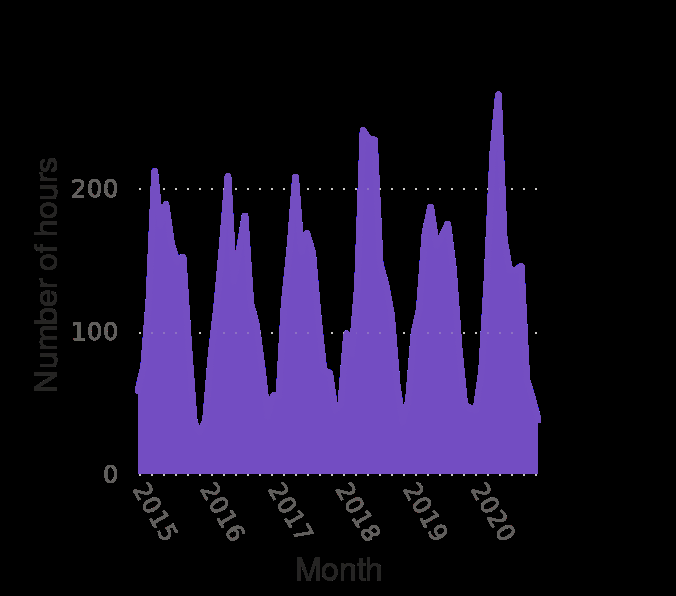<image>
What does the x-axis measure in the area chart? The x-axis in the area chart measures the months. What does the y-axis represent in the area chart?  The y-axis in the area chart represents the number of hours of sunlight. Is there any specific trend in the monthly sunlight hours over the mentioned years? The trend in the monthly sunlight hours is relatively consistent, except for the significantly higher hours in 2018 and 2020 and the lower hours in 2019. 